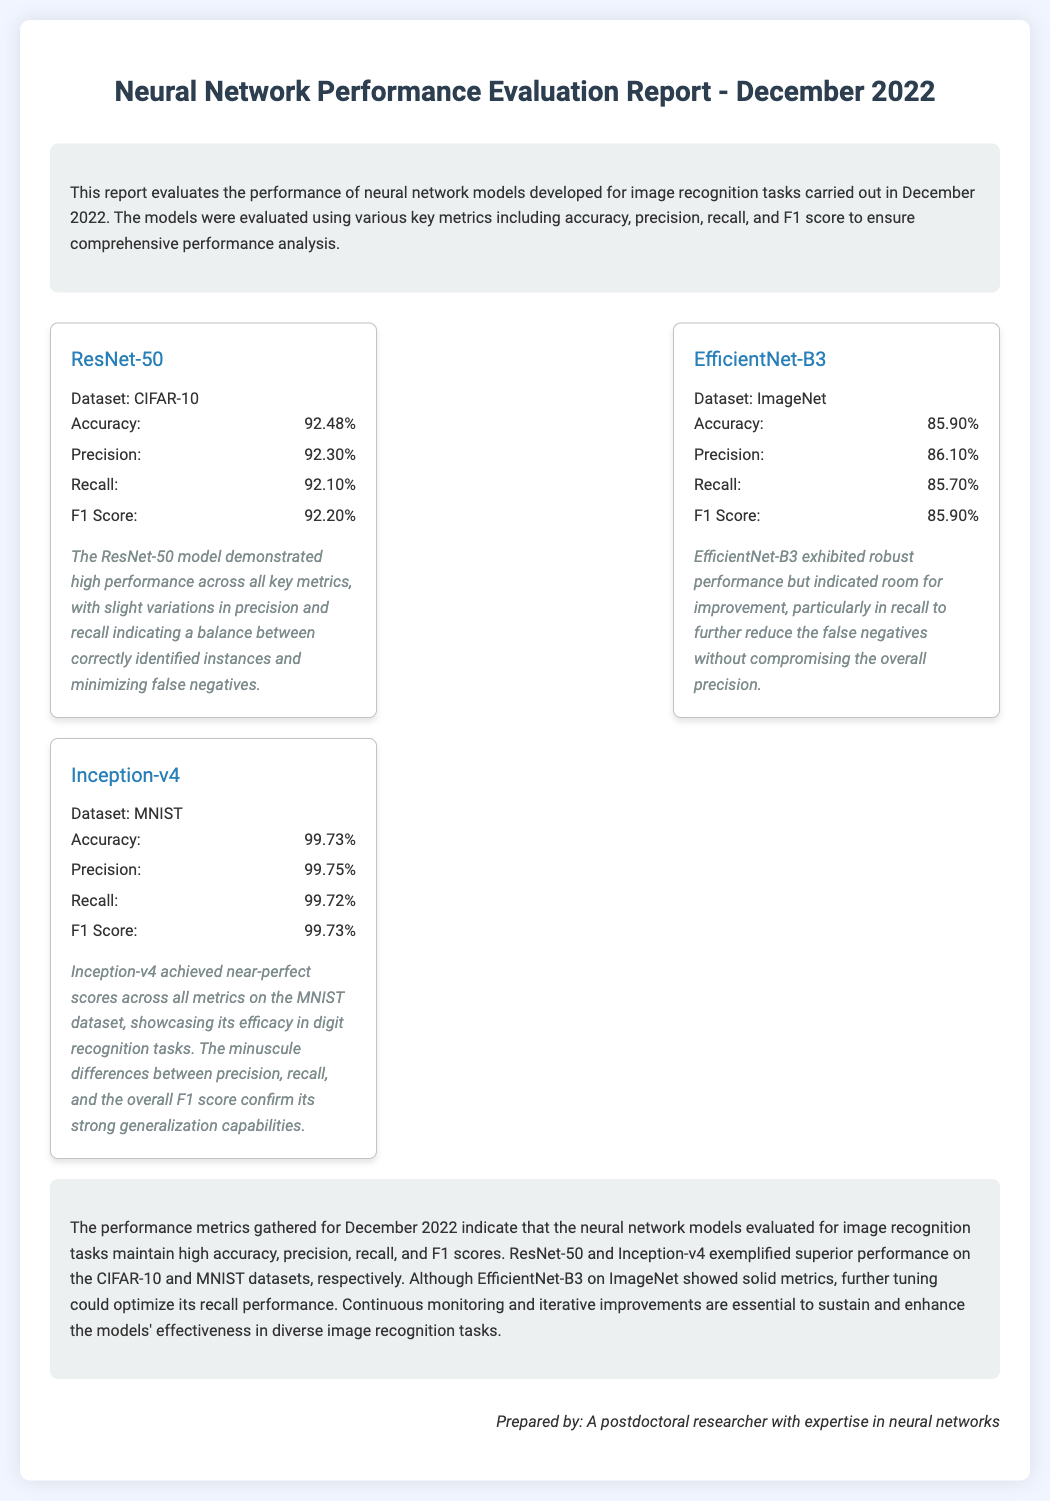What is the title of the report? The title of the report is clearly stated at the top of the document.
Answer: Neural Network Performance Evaluation Report - December 2022 Which dataset was used for the ResNet-50 model? The dataset used is mentioned in the model card for ResNet-50.
Answer: CIFAR-10 What is the F1 Score for EfficientNet-B3? The F1 Score is listed among the metrics for the EfficientNet-B3 model.
Answer: 85.90% What was the accuracy of the Inception-v4 model? The accuracy is one of the key metrics included in the Inception-v4 model results.
Answer: 99.73% Which model achieved the highest recall? The document discusses the recall metrics, allowing comparison among models.
Answer: Inception-v4 What observation is made about EfficientNet-B3? The observations section provides insights into the performance of the EfficientNet-B3 model.
Answer: Room for improvement Who prepared the report? The individual's name is mentioned in the signature section at the end of the document.
Answer: A postdoctoral researcher with expertise in neural networks What is the average accuracy of the models assessed? To find the average, one would sum the accuracies of all models and divide by the number of models.
Answer: 92.70% What is the primary focus of this report? The introduction briefly mentions the core subject of the evaluation report.
Answer: Image recognition tasks 